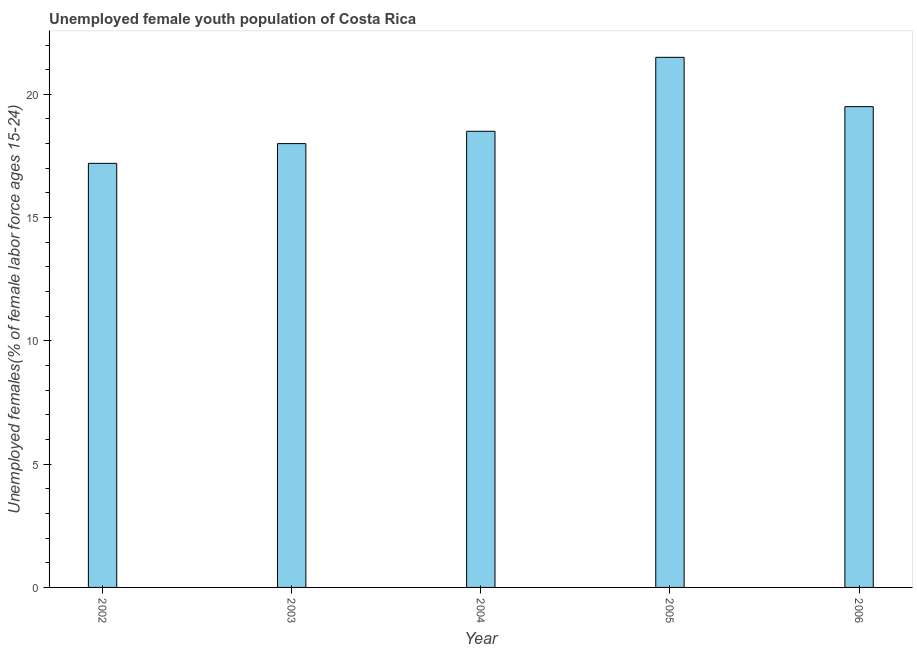Does the graph contain any zero values?
Keep it short and to the point. No. Does the graph contain grids?
Offer a terse response. No. What is the title of the graph?
Your response must be concise. Unemployed female youth population of Costa Rica. What is the label or title of the Y-axis?
Make the answer very short. Unemployed females(% of female labor force ages 15-24). What is the unemployed female youth in 2002?
Your response must be concise. 17.2. Across all years, what is the maximum unemployed female youth?
Your answer should be compact. 21.5. Across all years, what is the minimum unemployed female youth?
Your answer should be compact. 17.2. In which year was the unemployed female youth maximum?
Your response must be concise. 2005. In which year was the unemployed female youth minimum?
Your answer should be compact. 2002. What is the sum of the unemployed female youth?
Provide a short and direct response. 94.7. What is the difference between the unemployed female youth in 2003 and 2004?
Ensure brevity in your answer.  -0.5. What is the average unemployed female youth per year?
Provide a succinct answer. 18.94. What is the ratio of the unemployed female youth in 2005 to that in 2006?
Provide a succinct answer. 1.1. Is the unemployed female youth in 2003 less than that in 2005?
Offer a terse response. Yes. What is the difference between the highest and the second highest unemployed female youth?
Ensure brevity in your answer.  2. What is the difference between the highest and the lowest unemployed female youth?
Your answer should be very brief. 4.3. In how many years, is the unemployed female youth greater than the average unemployed female youth taken over all years?
Make the answer very short. 2. How many bars are there?
Offer a terse response. 5. How many years are there in the graph?
Offer a very short reply. 5. What is the difference between two consecutive major ticks on the Y-axis?
Offer a terse response. 5. Are the values on the major ticks of Y-axis written in scientific E-notation?
Keep it short and to the point. No. What is the Unemployed females(% of female labor force ages 15-24) in 2002?
Offer a very short reply. 17.2. What is the Unemployed females(% of female labor force ages 15-24) in 2005?
Your response must be concise. 21.5. What is the difference between the Unemployed females(% of female labor force ages 15-24) in 2002 and 2004?
Provide a short and direct response. -1.3. What is the difference between the Unemployed females(% of female labor force ages 15-24) in 2002 and 2005?
Offer a terse response. -4.3. What is the difference between the Unemployed females(% of female labor force ages 15-24) in 2003 and 2006?
Provide a succinct answer. -1.5. What is the difference between the Unemployed females(% of female labor force ages 15-24) in 2005 and 2006?
Your answer should be very brief. 2. What is the ratio of the Unemployed females(% of female labor force ages 15-24) in 2002 to that in 2003?
Ensure brevity in your answer.  0.96. What is the ratio of the Unemployed females(% of female labor force ages 15-24) in 2002 to that in 2004?
Make the answer very short. 0.93. What is the ratio of the Unemployed females(% of female labor force ages 15-24) in 2002 to that in 2005?
Your answer should be compact. 0.8. What is the ratio of the Unemployed females(% of female labor force ages 15-24) in 2002 to that in 2006?
Make the answer very short. 0.88. What is the ratio of the Unemployed females(% of female labor force ages 15-24) in 2003 to that in 2005?
Your answer should be very brief. 0.84. What is the ratio of the Unemployed females(% of female labor force ages 15-24) in 2003 to that in 2006?
Offer a terse response. 0.92. What is the ratio of the Unemployed females(% of female labor force ages 15-24) in 2004 to that in 2005?
Your answer should be very brief. 0.86. What is the ratio of the Unemployed females(% of female labor force ages 15-24) in 2004 to that in 2006?
Provide a short and direct response. 0.95. What is the ratio of the Unemployed females(% of female labor force ages 15-24) in 2005 to that in 2006?
Provide a short and direct response. 1.1. 